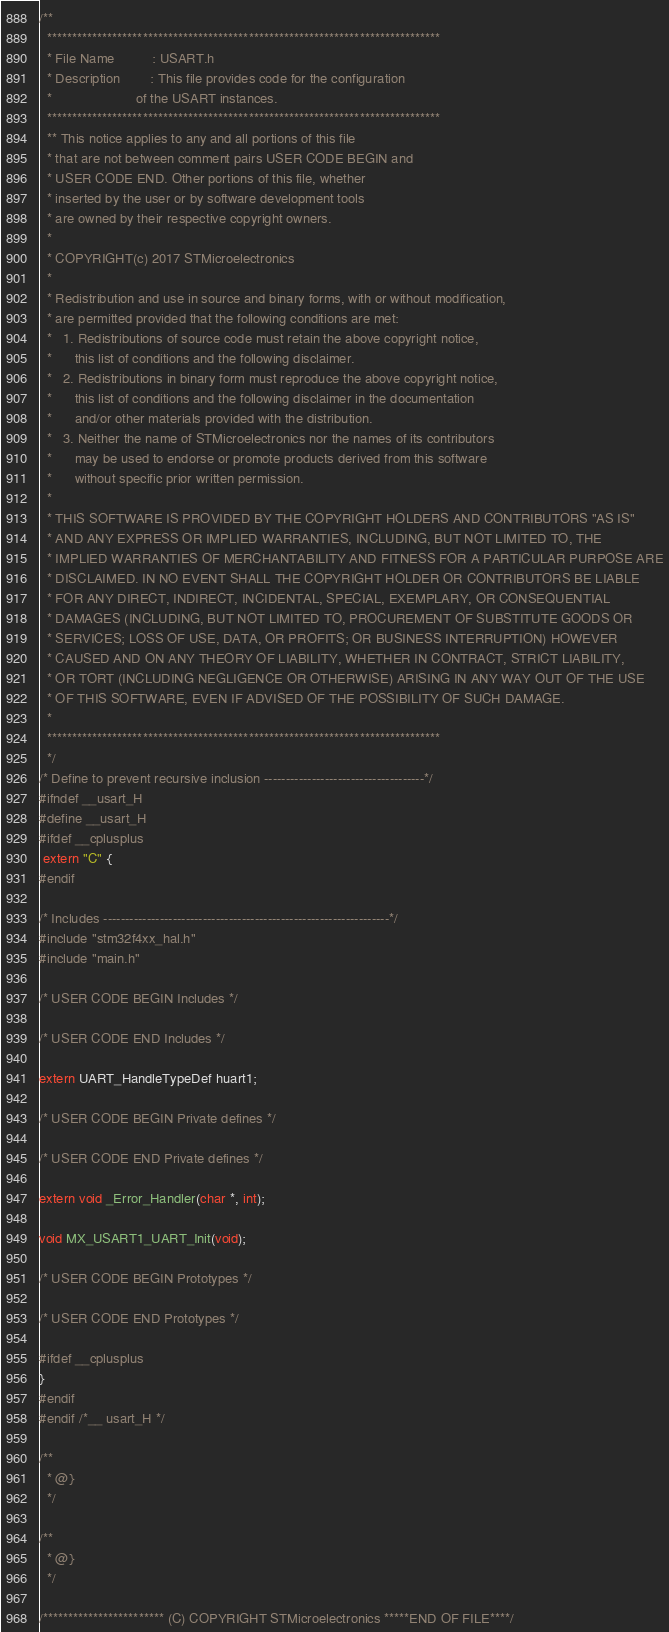<code> <loc_0><loc_0><loc_500><loc_500><_C_>/**
  ******************************************************************************
  * File Name          : USART.h
  * Description        : This file provides code for the configuration
  *                      of the USART instances.
  ******************************************************************************
  ** This notice applies to any and all portions of this file
  * that are not between comment pairs USER CODE BEGIN and
  * USER CODE END. Other portions of this file, whether 
  * inserted by the user or by software development tools
  * are owned by their respective copyright owners.
  *
  * COPYRIGHT(c) 2017 STMicroelectronics
  *
  * Redistribution and use in source and binary forms, with or without modification,
  * are permitted provided that the following conditions are met:
  *   1. Redistributions of source code must retain the above copyright notice,
  *      this list of conditions and the following disclaimer.
  *   2. Redistributions in binary form must reproduce the above copyright notice,
  *      this list of conditions and the following disclaimer in the documentation
  *      and/or other materials provided with the distribution.
  *   3. Neither the name of STMicroelectronics nor the names of its contributors
  *      may be used to endorse or promote products derived from this software
  *      without specific prior written permission.
  *
  * THIS SOFTWARE IS PROVIDED BY THE COPYRIGHT HOLDERS AND CONTRIBUTORS "AS IS"
  * AND ANY EXPRESS OR IMPLIED WARRANTIES, INCLUDING, BUT NOT LIMITED TO, THE
  * IMPLIED WARRANTIES OF MERCHANTABILITY AND FITNESS FOR A PARTICULAR PURPOSE ARE
  * DISCLAIMED. IN NO EVENT SHALL THE COPYRIGHT HOLDER OR CONTRIBUTORS BE LIABLE
  * FOR ANY DIRECT, INDIRECT, INCIDENTAL, SPECIAL, EXEMPLARY, OR CONSEQUENTIAL
  * DAMAGES (INCLUDING, BUT NOT LIMITED TO, PROCUREMENT OF SUBSTITUTE GOODS OR
  * SERVICES; LOSS OF USE, DATA, OR PROFITS; OR BUSINESS INTERRUPTION) HOWEVER
  * CAUSED AND ON ANY THEORY OF LIABILITY, WHETHER IN CONTRACT, STRICT LIABILITY,
  * OR TORT (INCLUDING NEGLIGENCE OR OTHERWISE) ARISING IN ANY WAY OUT OF THE USE
  * OF THIS SOFTWARE, EVEN IF ADVISED OF THE POSSIBILITY OF SUCH DAMAGE.
  *
  ******************************************************************************
  */
/* Define to prevent recursive inclusion -------------------------------------*/
#ifndef __usart_H
#define __usart_H
#ifdef __cplusplus
 extern "C" {
#endif

/* Includes ------------------------------------------------------------------*/
#include "stm32f4xx_hal.h"
#include "main.h"

/* USER CODE BEGIN Includes */

/* USER CODE END Includes */

extern UART_HandleTypeDef huart1;

/* USER CODE BEGIN Private defines */

/* USER CODE END Private defines */

extern void _Error_Handler(char *, int);

void MX_USART1_UART_Init(void);

/* USER CODE BEGIN Prototypes */

/* USER CODE END Prototypes */

#ifdef __cplusplus
}
#endif
#endif /*__ usart_H */

/**
  * @}
  */

/**
  * @}
  */

/************************ (C) COPYRIGHT STMicroelectronics *****END OF FILE****/
</code> 